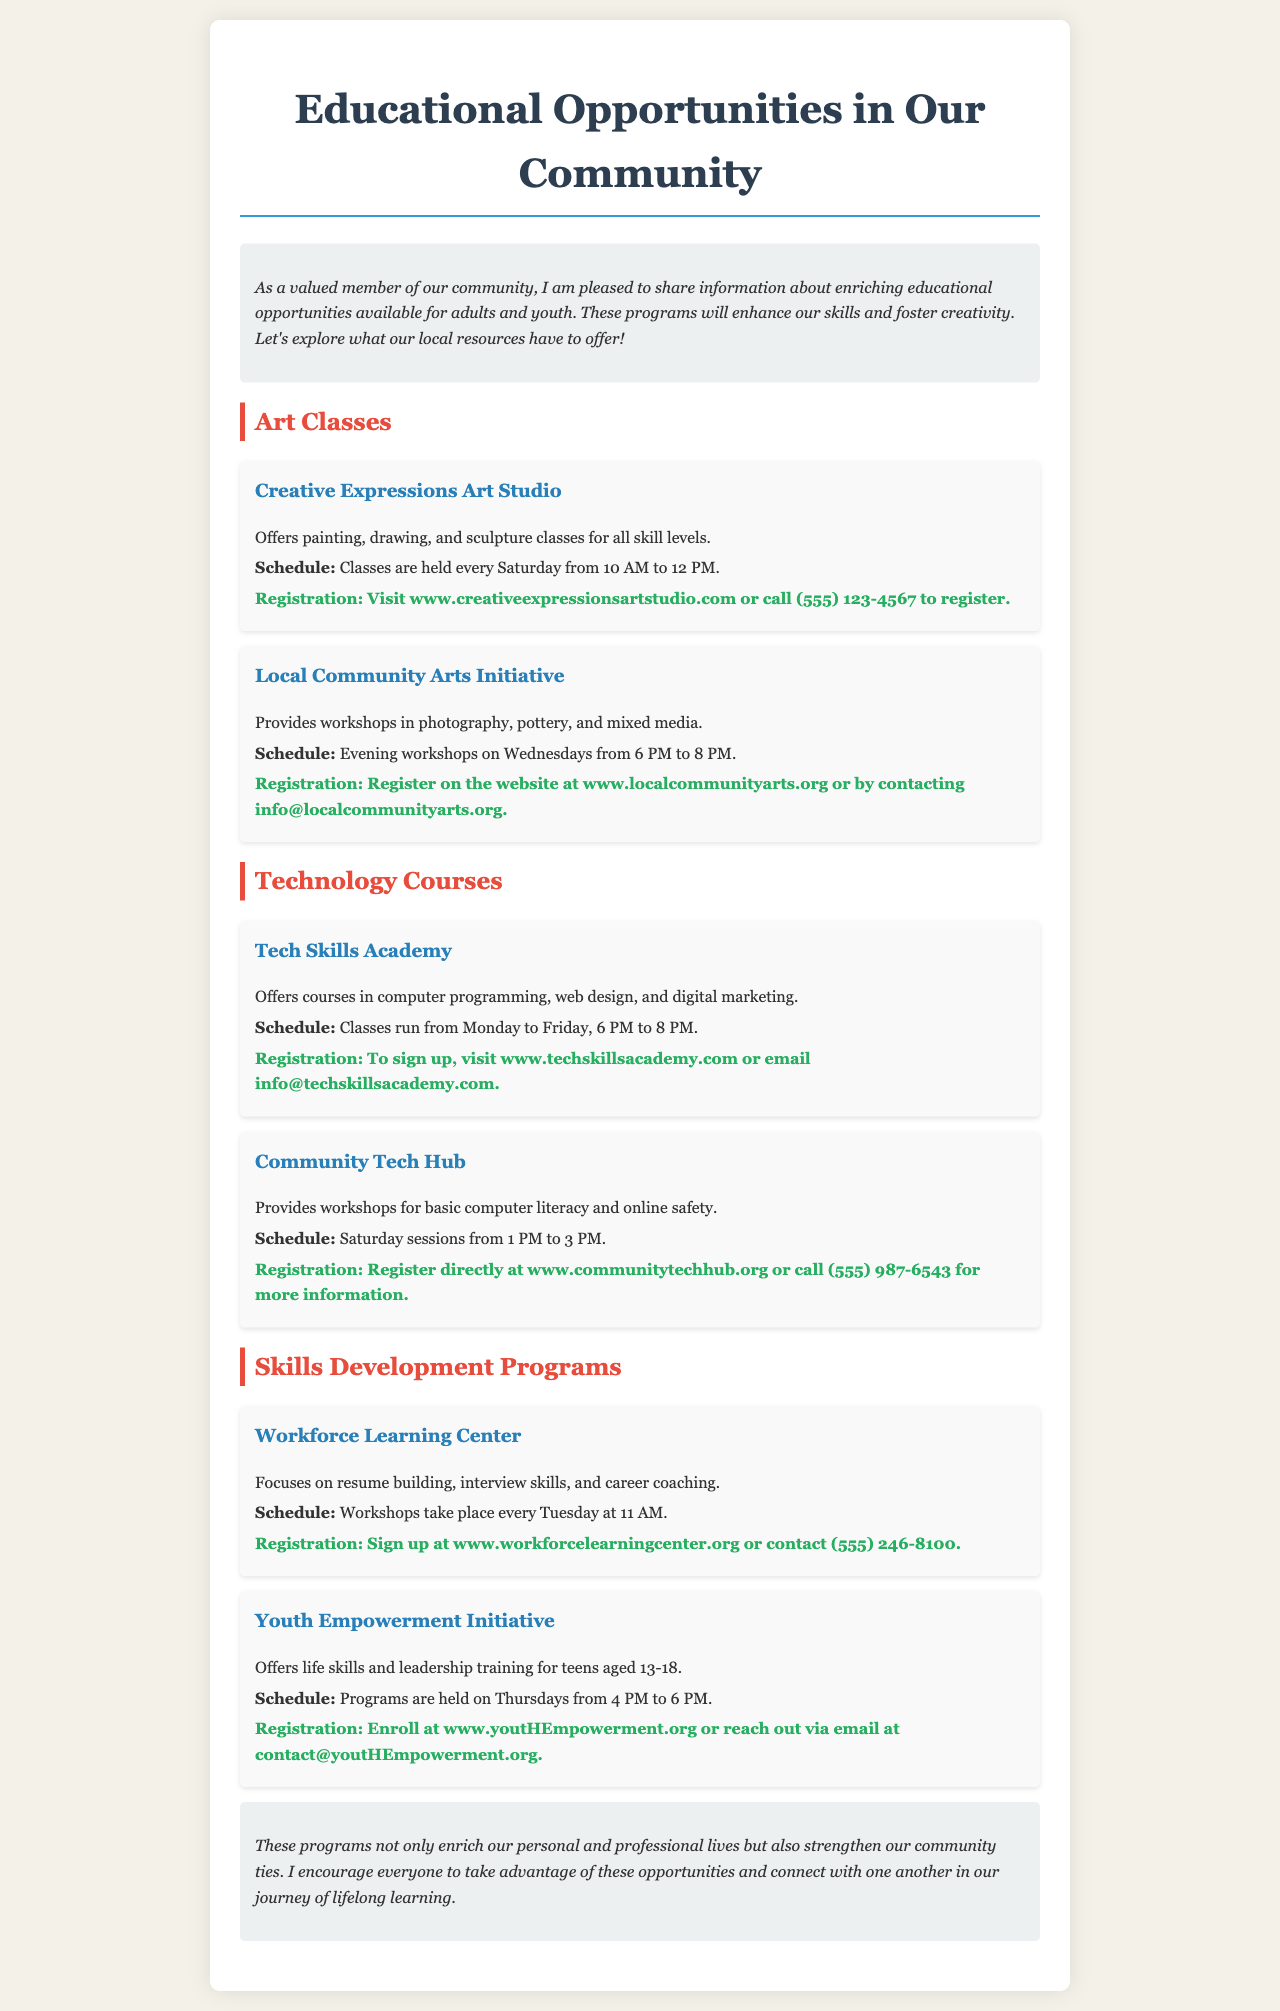What are the two types of classes offered by Creative Expressions Art Studio? Creative Expressions Art Studio offers painting and drawing classes for all skill levels.
Answer: painting, drawing What day of the week does the Youth Empowerment Initiative hold programs? The Youth Empowerment Initiative's programs are held on Thursdays.
Answer: Thursdays What is the schedule for Tech Skills Academy's classes? Tech Skills Academy's classes run from Monday to Friday, 6 PM to 8 PM.
Answer: Monday to Friday, 6 PM to 8 PM What type of training does the Workforce Learning Center provide? The Workforce Learning Center focuses on resume building, interview skills, and career coaching for personal development.
Answer: resume building, interview skills, career coaching How can one register for the Local Community Arts Initiative workshops? To register for the Local Community Arts Initiative workshops, you can register on the website or contact them via email.
Answer: www.localcommunityarts.org or info@localcommunityarts.org 